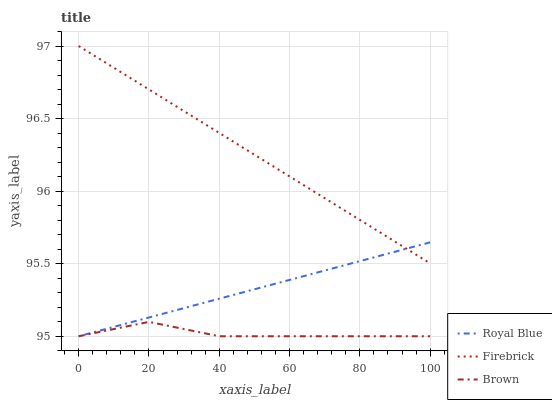Does Firebrick have the minimum area under the curve?
Answer yes or no. No. Does Brown have the maximum area under the curve?
Answer yes or no. No. Is Brown the smoothest?
Answer yes or no. No. Is Firebrick the roughest?
Answer yes or no. No. Does Firebrick have the lowest value?
Answer yes or no. No. Does Brown have the highest value?
Answer yes or no. No. Is Brown less than Firebrick?
Answer yes or no. Yes. Is Firebrick greater than Brown?
Answer yes or no. Yes. Does Brown intersect Firebrick?
Answer yes or no. No. 